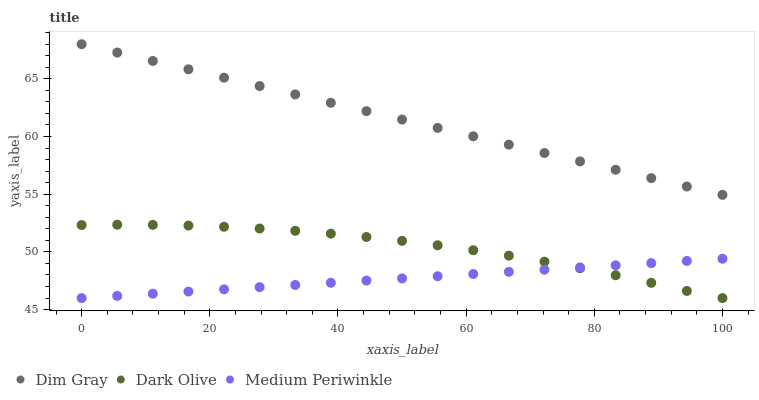Does Medium Periwinkle have the minimum area under the curve?
Answer yes or no. Yes. Does Dim Gray have the maximum area under the curve?
Answer yes or no. Yes. Does Dim Gray have the minimum area under the curve?
Answer yes or no. No. Does Medium Periwinkle have the maximum area under the curve?
Answer yes or no. No. Is Medium Periwinkle the smoothest?
Answer yes or no. Yes. Is Dark Olive the roughest?
Answer yes or no. Yes. Is Dim Gray the smoothest?
Answer yes or no. No. Is Dim Gray the roughest?
Answer yes or no. No. Does Dark Olive have the lowest value?
Answer yes or no. Yes. Does Dim Gray have the lowest value?
Answer yes or no. No. Does Dim Gray have the highest value?
Answer yes or no. Yes. Does Medium Periwinkle have the highest value?
Answer yes or no. No. Is Dark Olive less than Dim Gray?
Answer yes or no. Yes. Is Dim Gray greater than Dark Olive?
Answer yes or no. Yes. Does Medium Periwinkle intersect Dark Olive?
Answer yes or no. Yes. Is Medium Periwinkle less than Dark Olive?
Answer yes or no. No. Is Medium Periwinkle greater than Dark Olive?
Answer yes or no. No. Does Dark Olive intersect Dim Gray?
Answer yes or no. No. 